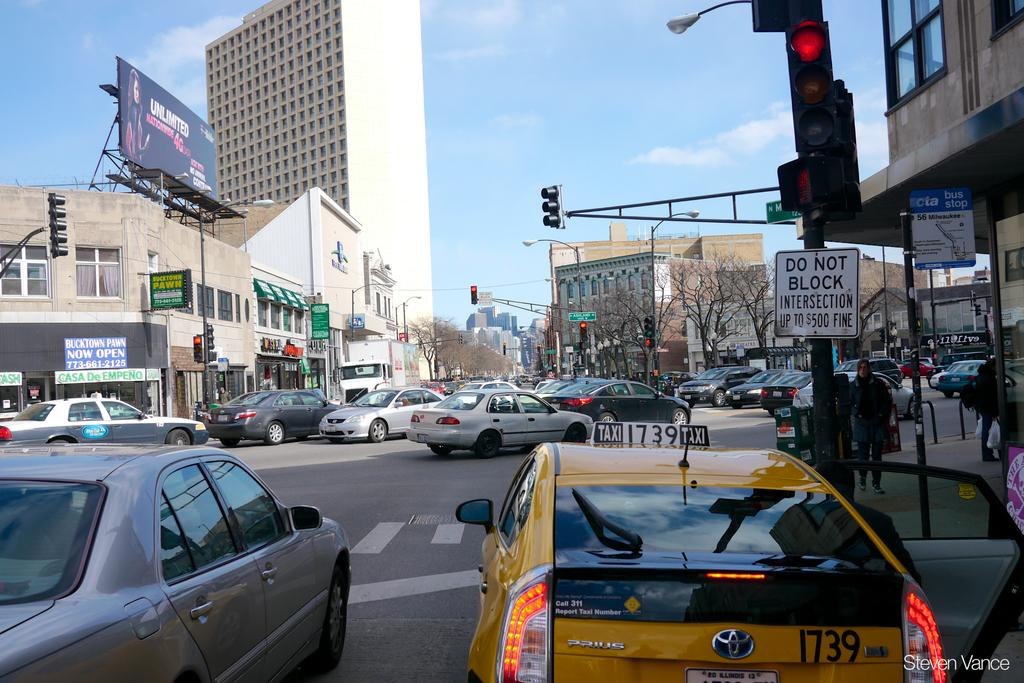<image>
Create a compact narrative representing the image presented. Busy street with a square white sign that has black letters Do Not Block Intersection up to $500 fine. 